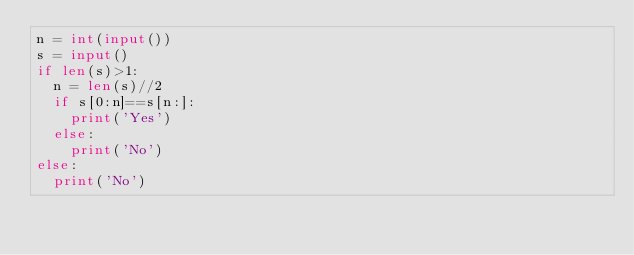<code> <loc_0><loc_0><loc_500><loc_500><_Python_>n = int(input())
s = input()
if len(s)>1:
  n = len(s)//2
  if s[0:n]==s[n:]:
    print('Yes')
  else:
    print('No')
else:
  print('No')</code> 